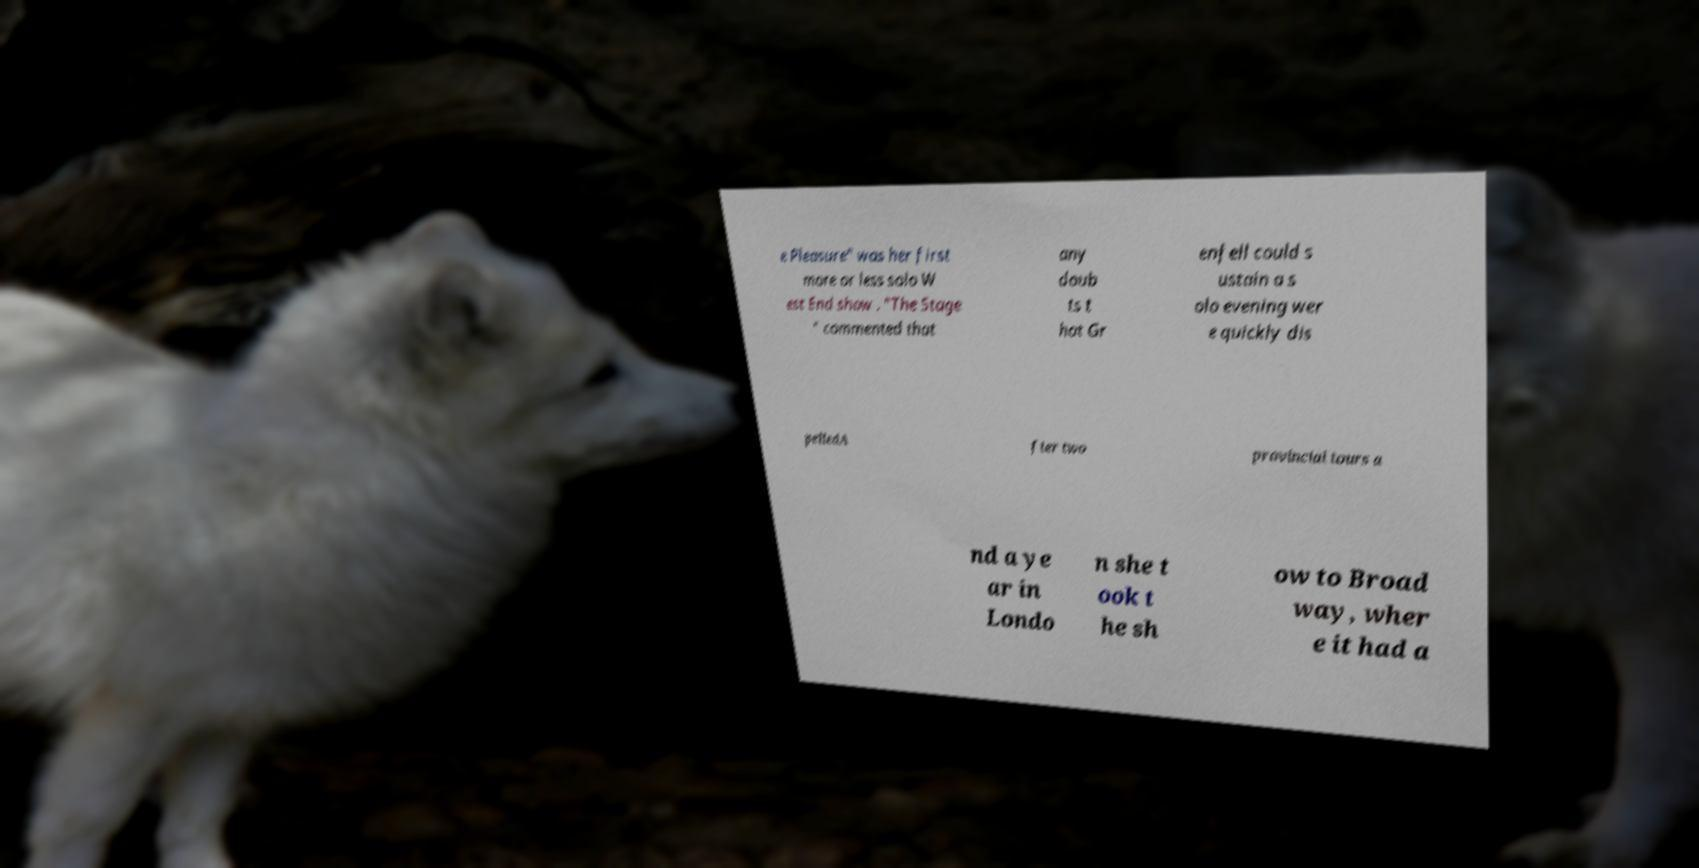Can you accurately transcribe the text from the provided image for me? e Pleasure" was her first more or less solo W est End show . "The Stage " commented that any doub ts t hat Gr enfell could s ustain a s olo evening wer e quickly dis pelledA fter two provincial tours a nd a ye ar in Londo n she t ook t he sh ow to Broad way, wher e it had a 